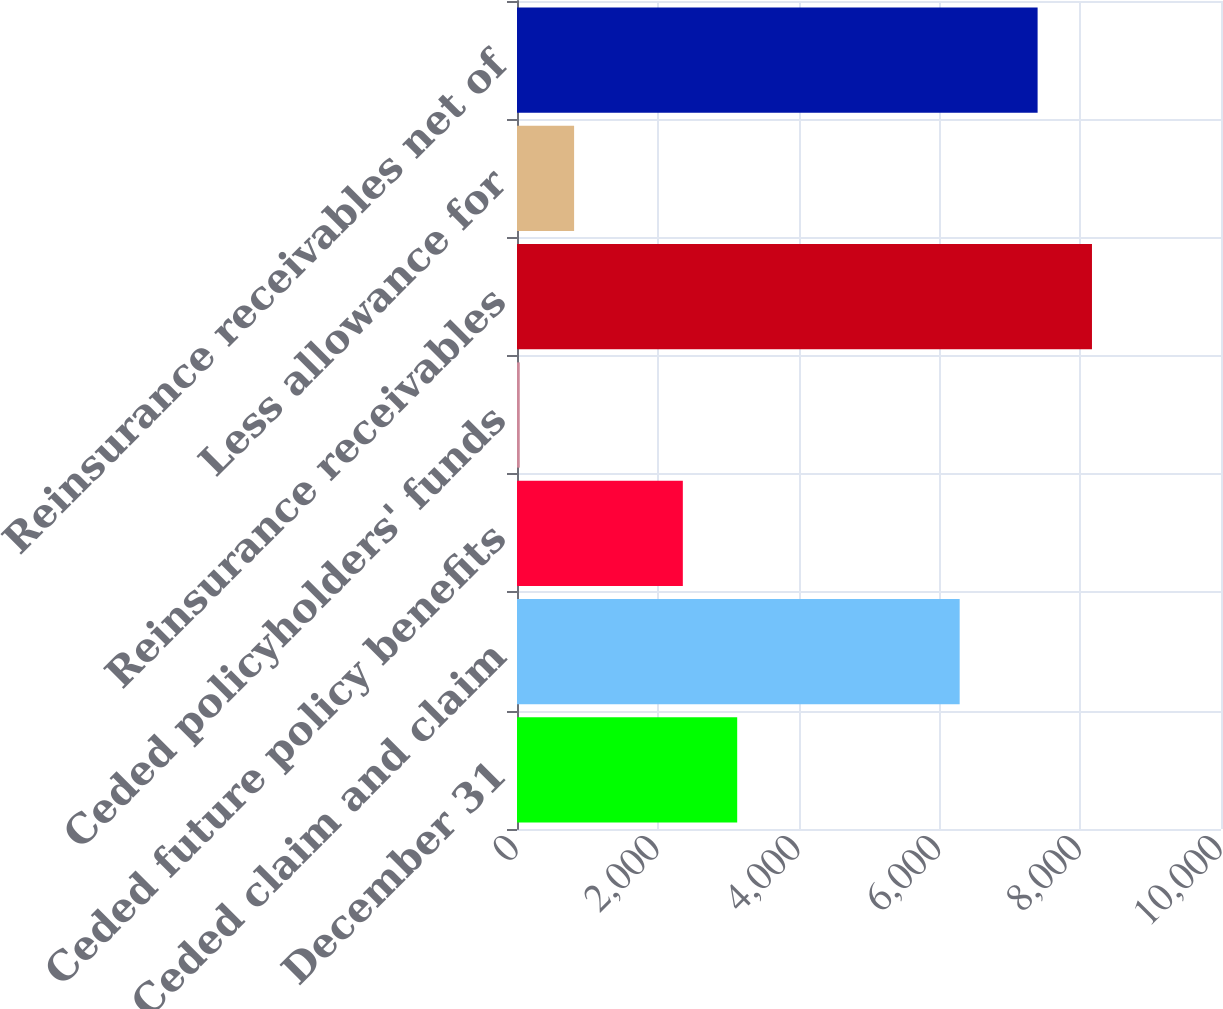<chart> <loc_0><loc_0><loc_500><loc_500><bar_chart><fcel>December 31<fcel>Ceded claim and claim<fcel>Ceded future policy benefits<fcel>Ceded policyholders' funds<fcel>Reinsurance receivables<fcel>Less allowance for<fcel>Reinsurance receivables net of<nl><fcel>3127.8<fcel>6288<fcel>2355.6<fcel>39<fcel>8167.2<fcel>811.2<fcel>7395<nl></chart> 